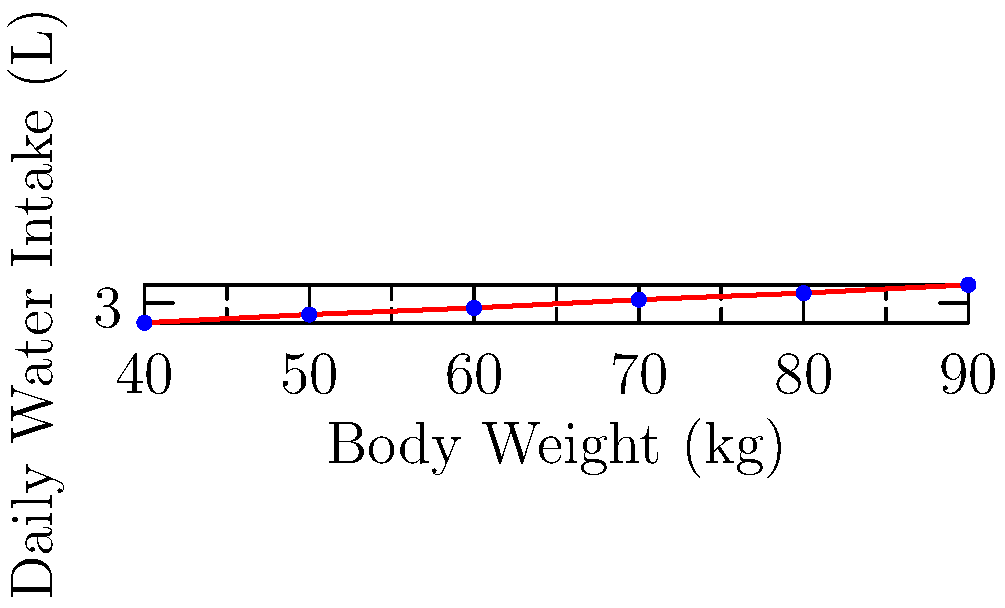As a parent concerned about promoting healthy habits, you're researching the relationship between body weight and daily water intake. The scatter plot shows this relationship for adults with moderate activity levels. If your child weighs 55 kg, estimate their recommended daily water intake in liters based on the trend shown in the graph. To estimate the recommended daily water intake for a 55 kg child, we'll follow these steps:

1. Observe the trend in the scatter plot: As body weight increases, daily water intake also increases.

2. Locate the position of 55 kg on the x-axis (body weight).

3. Estimate where a point for 55 kg would fall on the trend line:
   - 50 kg corresponds to about 2.3 L
   - 60 kg corresponds to about 2.7 L
   - 55 kg is halfway between 50 kg and 60 kg

4. Estimate the y-value (water intake) for 55 kg:
   $2.3 L + \frac{2.7 L - 2.3 L}{2} = 2.3 L + 0.2 L = 2.5 L$

5. Round to the nearest 0.1 L for a practical estimate.

Therefore, based on the trend in the scatter plot, a 55 kg child with moderate activity level would need approximately 2.5 L of water daily.
Answer: 2.5 L 